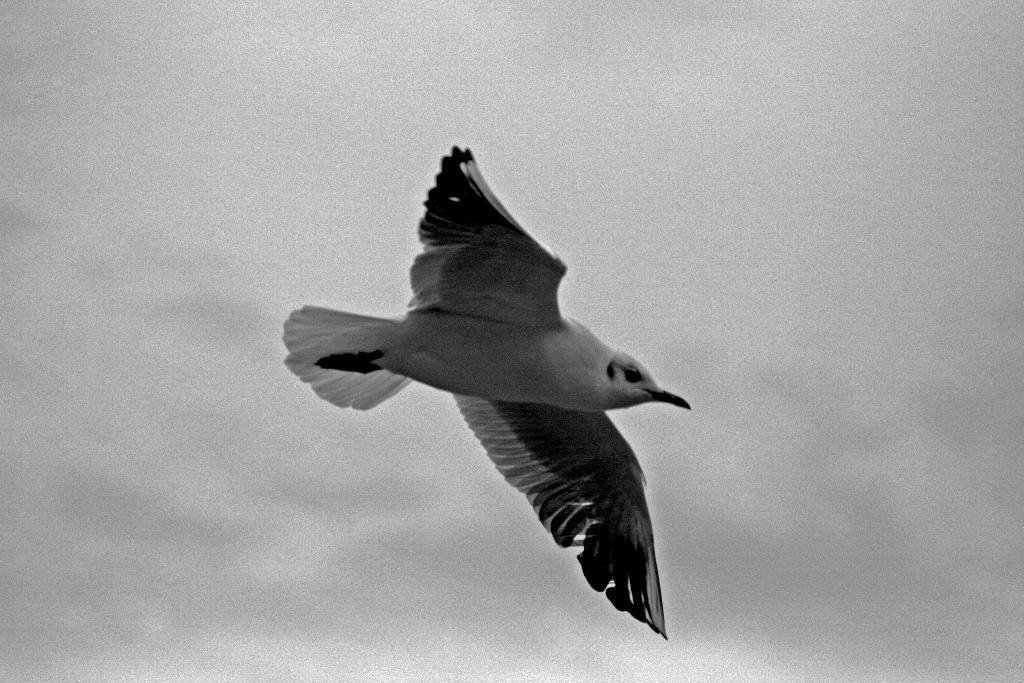Please provide a concise description of this image. This is a black and white picture where we can see one bird is flying. 